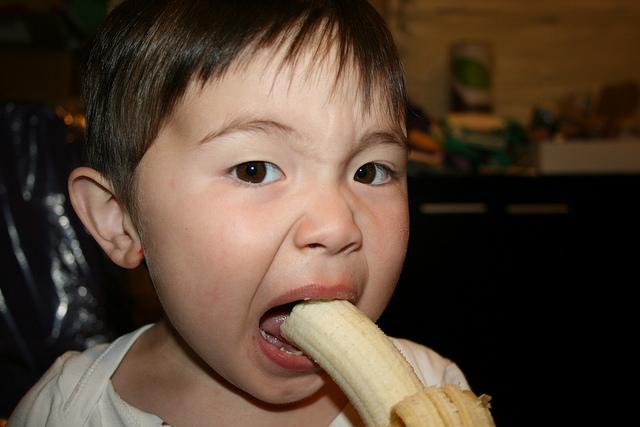What color of hair does the boy have?
Give a very brief answer. Brown. Is  the kid's hair curly?
Write a very short answer. No. Is the child trying to eat the banana peel?
Concise answer only. No. How much of the banana has he eaten?
Write a very short answer. 1 bite. Would this person enjoy a glass of orange juice right now?
Quick response, please. Yes. How many bruises are on the banana?
Answer briefly. 0. 